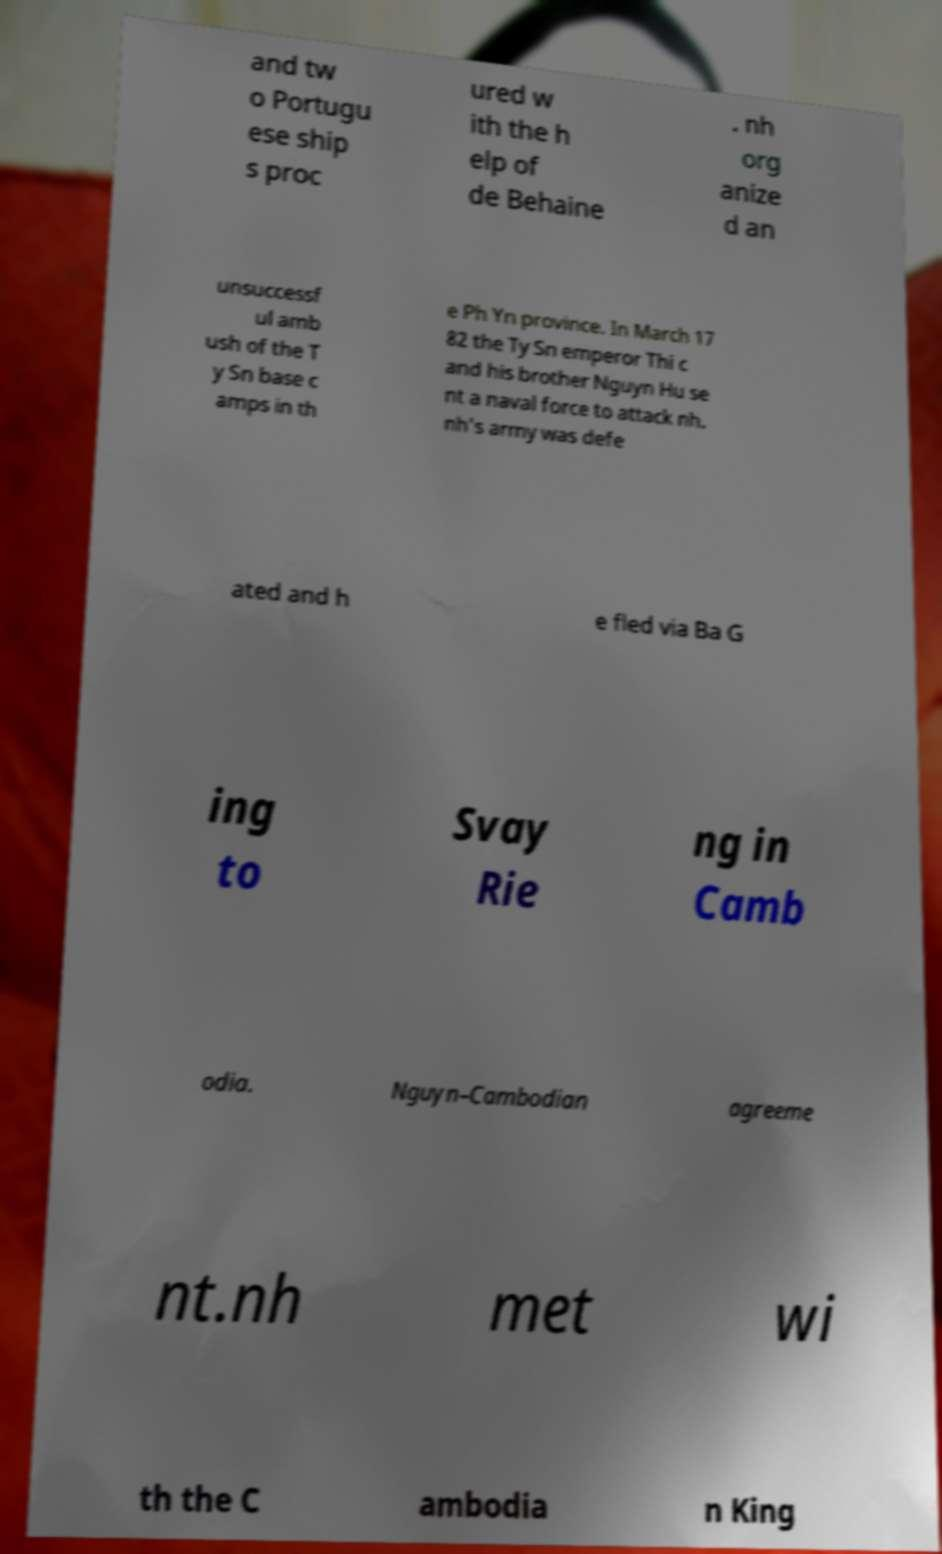For documentation purposes, I need the text within this image transcribed. Could you provide that? and tw o Portugu ese ship s proc ured w ith the h elp of de Behaine . nh org anize d an unsuccessf ul amb ush of the T y Sn base c amps in th e Ph Yn province. In March 17 82 the Ty Sn emperor Thi c and his brother Nguyn Hu se nt a naval force to attack nh. nh's army was defe ated and h e fled via Ba G ing to Svay Rie ng in Camb odia. Nguyn–Cambodian agreeme nt.nh met wi th the C ambodia n King 